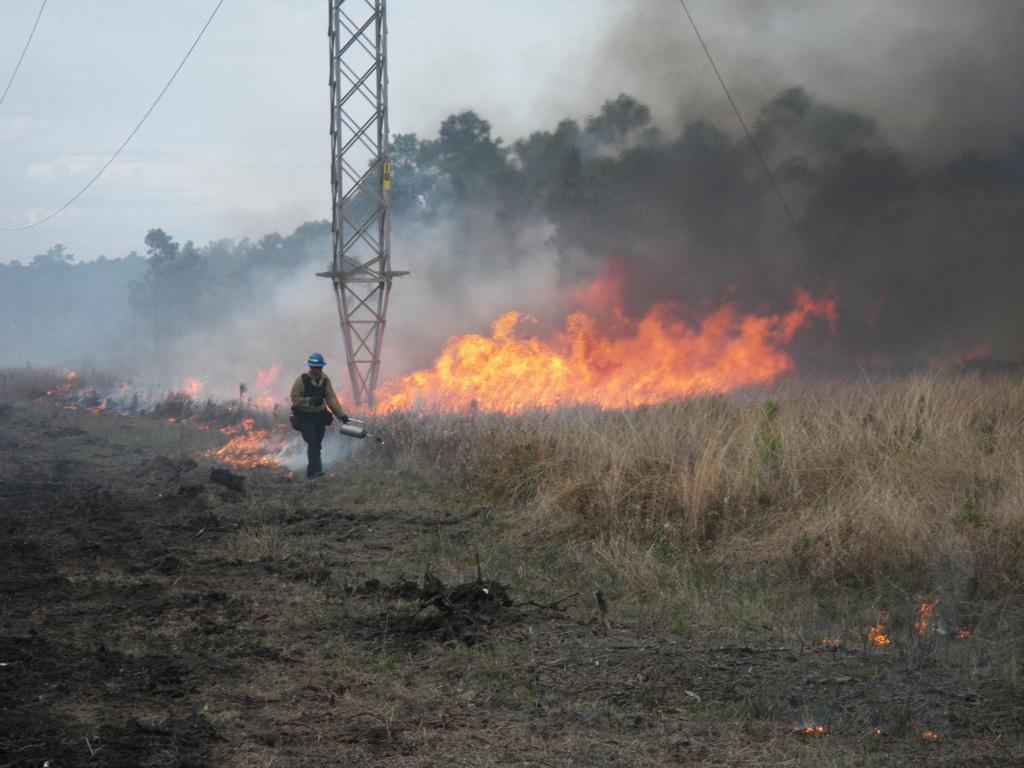How would you summarize this image in a sentence or two? In this picture we can see a person standing here, at the bottom there is grass, we can see fire here, in the background there are some trees, we can see a tower and smoke here, there is the sky at the top of the picture. 